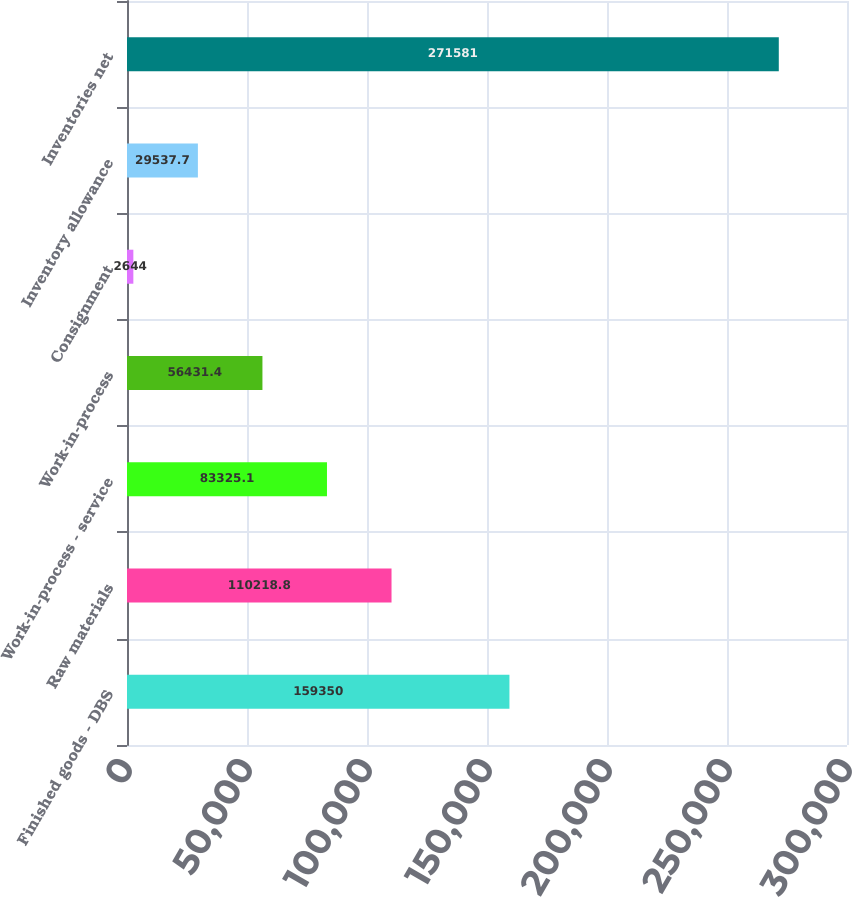Convert chart. <chart><loc_0><loc_0><loc_500><loc_500><bar_chart><fcel>Finished goods - DBS<fcel>Raw materials<fcel>Work-in-process - service<fcel>Work-in-process<fcel>Consignment<fcel>Inventory allowance<fcel>Inventories net<nl><fcel>159350<fcel>110219<fcel>83325.1<fcel>56431.4<fcel>2644<fcel>29537.7<fcel>271581<nl></chart> 